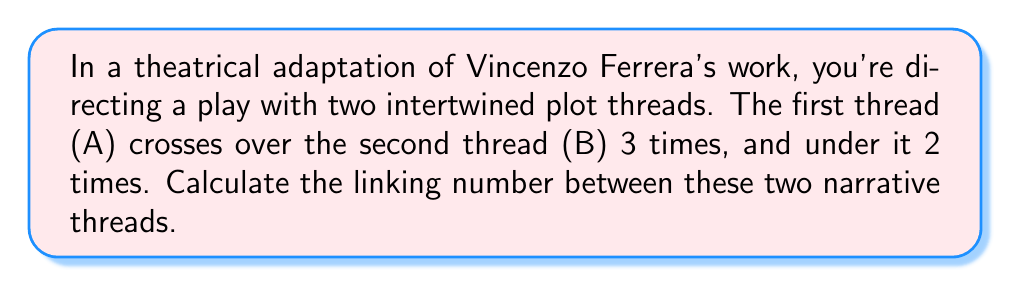Solve this math problem. To calculate the linking number between two intertwined plot threads, we can use the concept of linking number from knot theory. The linking number is a topological invariant that measures how much two curves are linked together.

Step 1: Assign orientations to the plot threads.
Let's assume both threads are oriented from left to right.

Step 2: Count the crossings.
- Thread A crosses over B: 3 times
- Thread A crosses under B: 2 times

Step 3: Assign values to the crossings.
- When A crosses over B (in the direction of orientation): +1
- When A crosses under B (in the direction of orientation): -1

Step 4: Calculate the sum of crossing values.
$$(3 \times (+1)) + (2 \times (-1)) = 3 - 2 = 1$$

Step 5: Calculate the linking number.
The linking number is half the sum of the crossing values:

$$\text{Linking Number} = \frac{1}{2} \sum \text{(Crossing Values)}$$

$$\text{Linking Number} = \frac{1}{2} (1) = \frac{1}{2}$$

This linking number of $\frac{1}{2}$ indicates that the two plot threads are linked together, creating a more complex narrative structure in your theatrical adaptation.
Answer: $\frac{1}{2}$ 